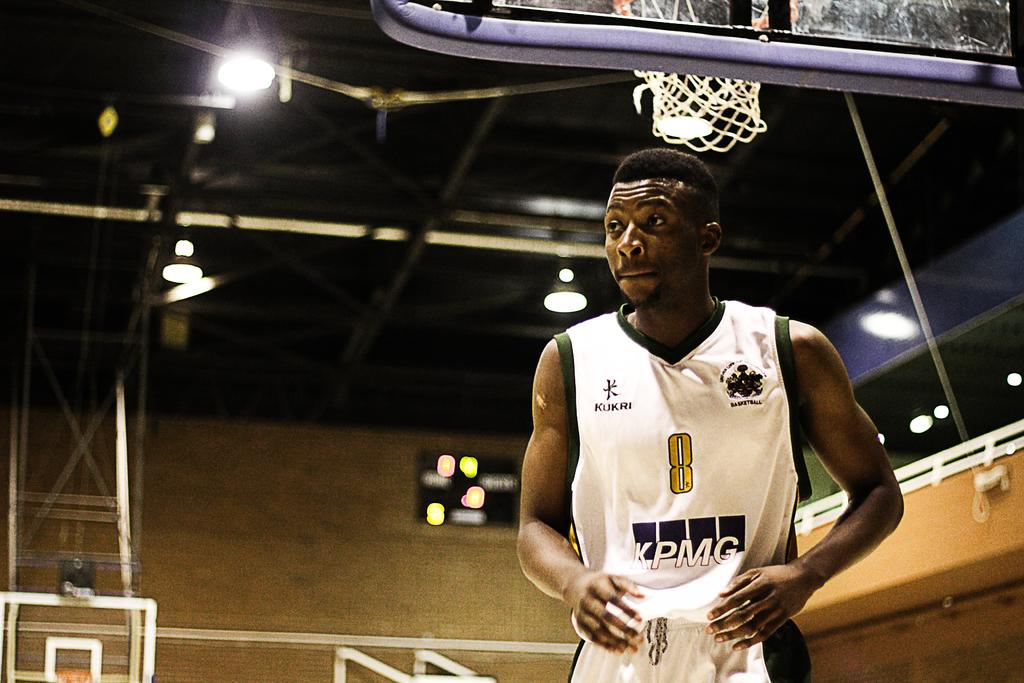<image>
Give a short and clear explanation of the subsequent image. A basketball player standing in an arena wearing number 8 